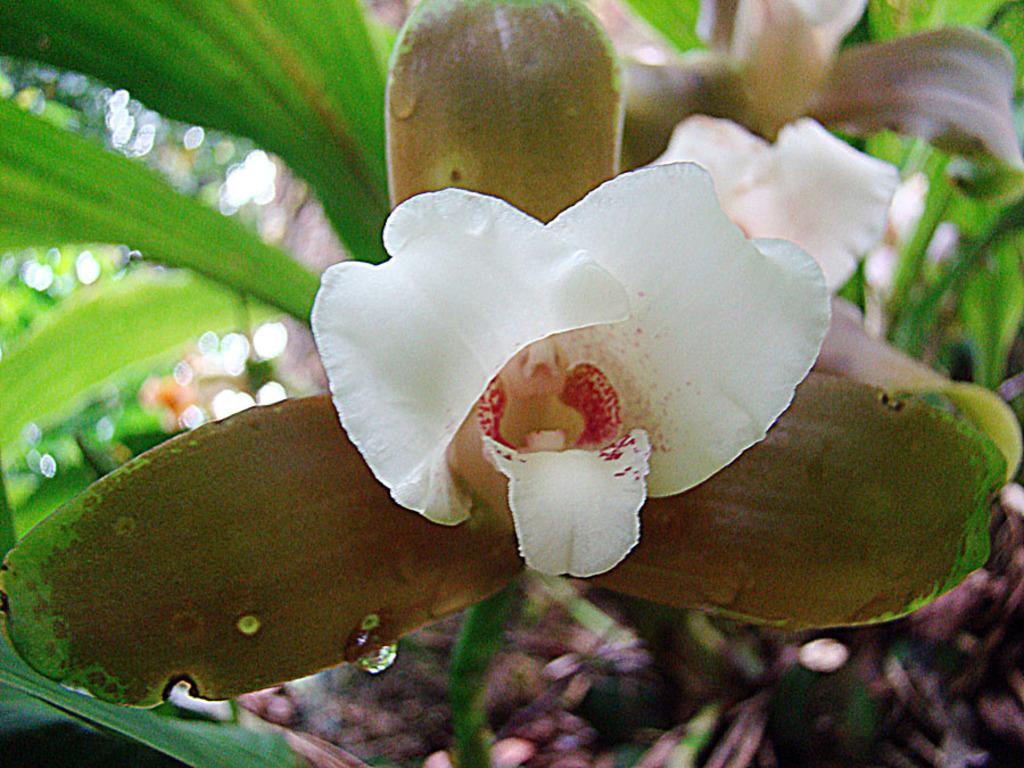What is located in the foreground of the image? There is a flower, leaves, and a water droplet in the foreground of the image. What type of vegetation can be seen in the foreground? The foreground features a flower and leaves. What is present in the background of the image? There is greenery and flowers in the background of the image. What type of book can be seen in the image? There is no book present in the image; it features a flower, leaves, and a water droplet in the foreground, with greenery and flowers in the background. What arithmetic problem is being solved in the image? There is no arithmetic problem present in the image. 